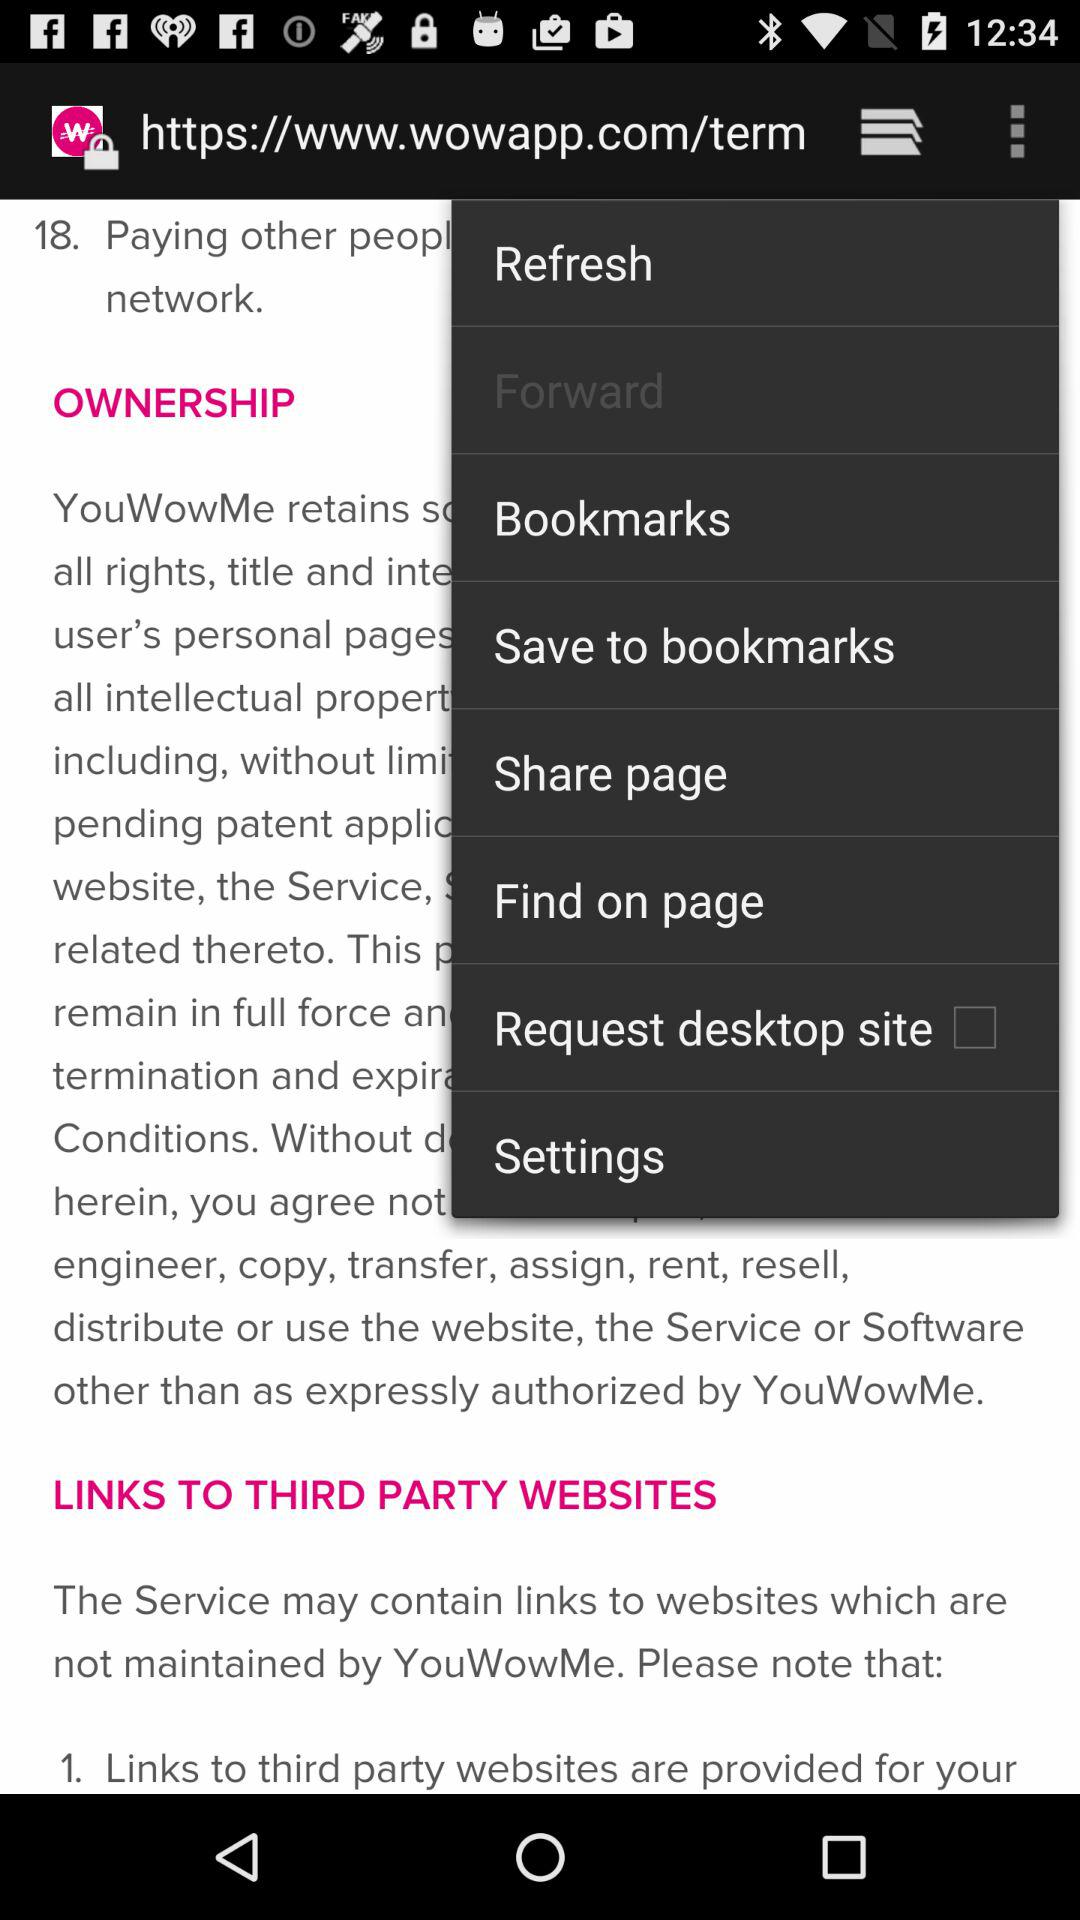How many links to third party websites are in the terms of service?
Answer the question using a single word or phrase. 1 